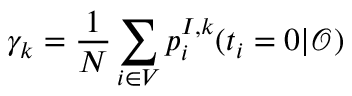Convert formula to latex. <formula><loc_0><loc_0><loc_500><loc_500>\gamma _ { k } = \frac { 1 } { N } \sum _ { i \in V } p _ { i } ^ { I , k } ( t _ { i } = 0 | \mathcal { O } )</formula> 